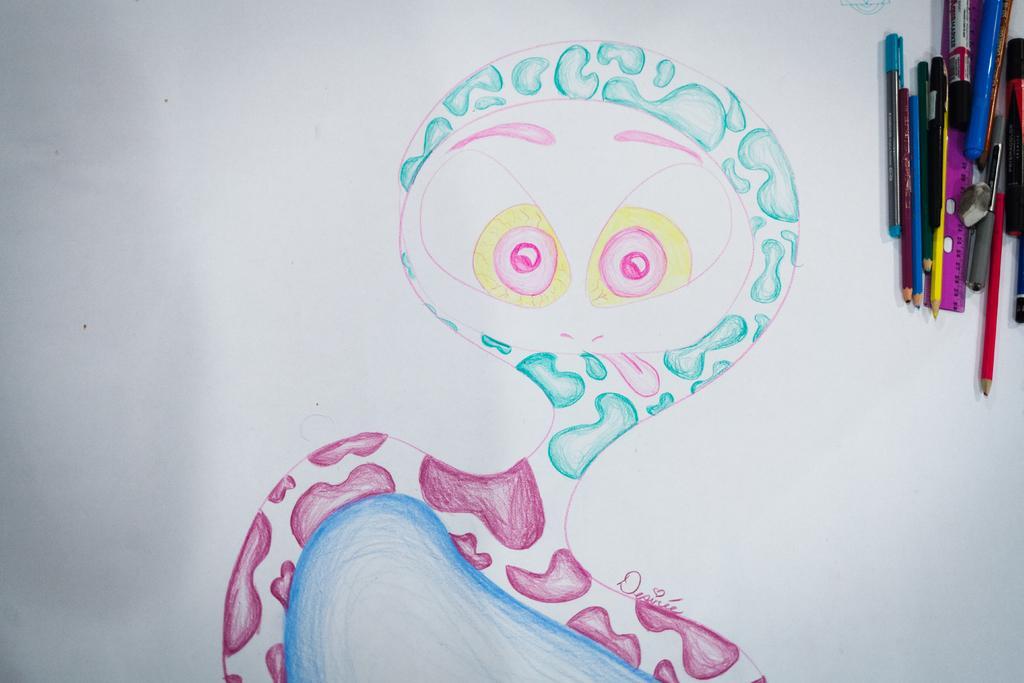Can you describe this image briefly? There is a drawing in different colors on the white color sheet. In the right top corner, there are color pencils, a pink color scale, a pen and a sketch. 